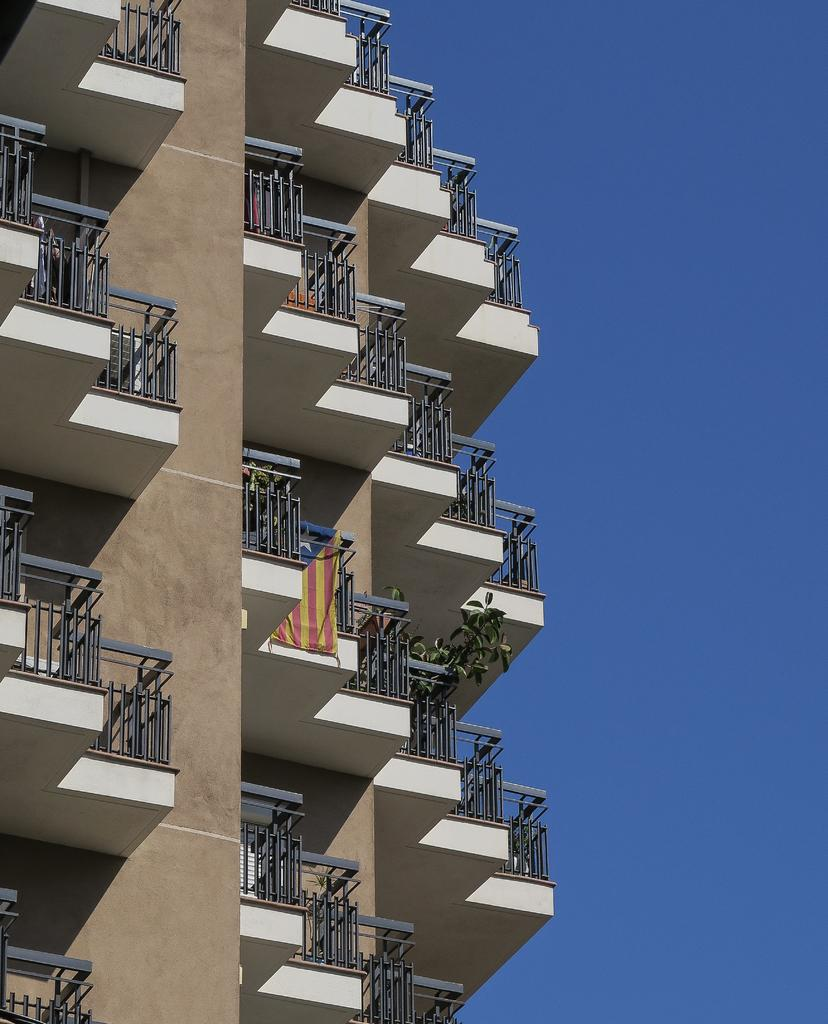What type of structure is present in the image? There is a building in the image. What else can be seen in the image besides the building? There is a cloth and plants visible in the image. What is the color of the sky in the image? The sky is blue in the image. What type of trouble is the truck experiencing during its voyage in the image? There is no truck or voyage present in the image; it only features a building, cloth, plants, and a blue sky. 